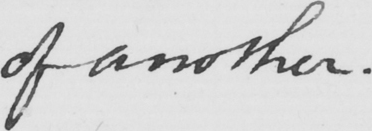What does this handwritten line say? of another . 